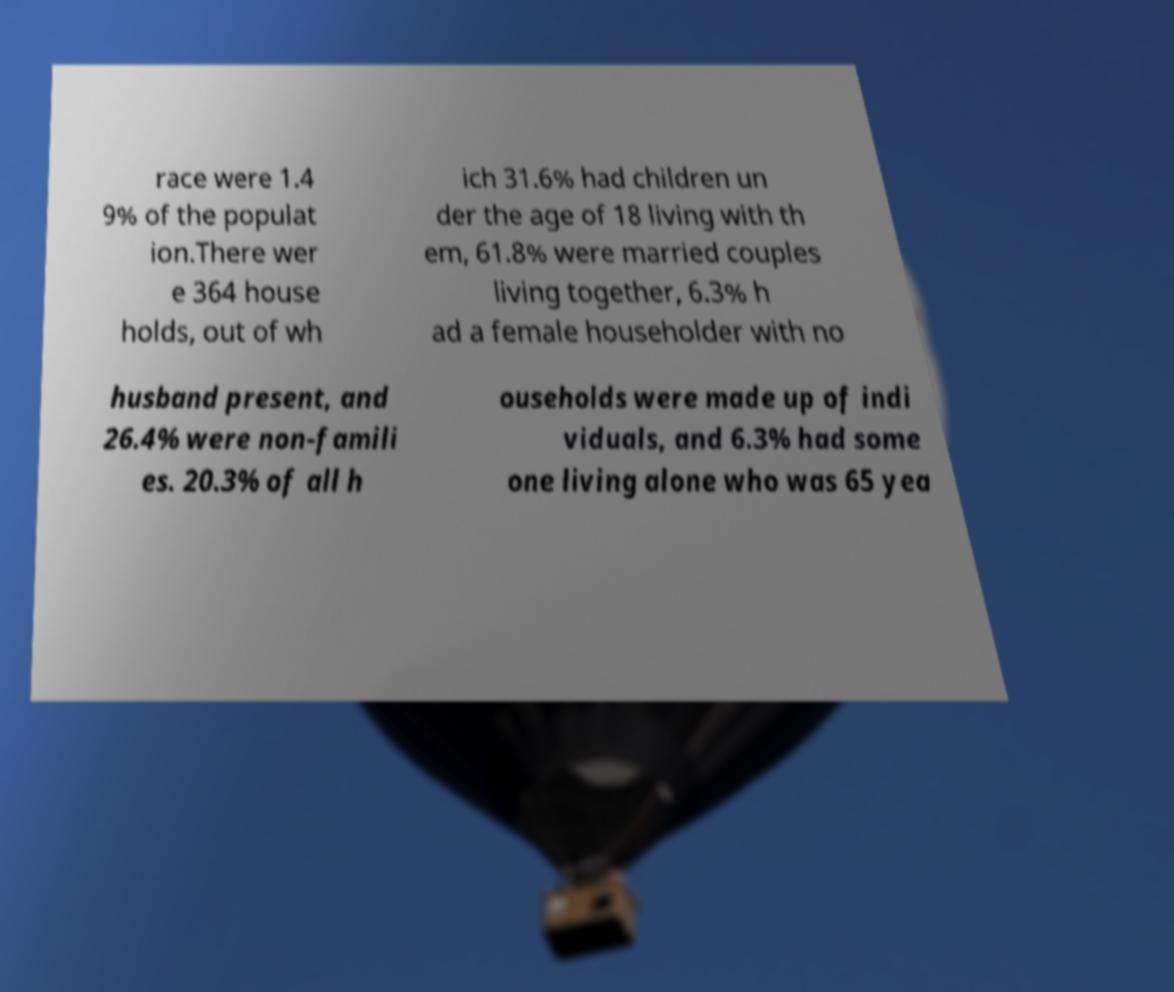Could you extract and type out the text from this image? race were 1.4 9% of the populat ion.There wer e 364 house holds, out of wh ich 31.6% had children un der the age of 18 living with th em, 61.8% were married couples living together, 6.3% h ad a female householder with no husband present, and 26.4% were non-famili es. 20.3% of all h ouseholds were made up of indi viduals, and 6.3% had some one living alone who was 65 yea 